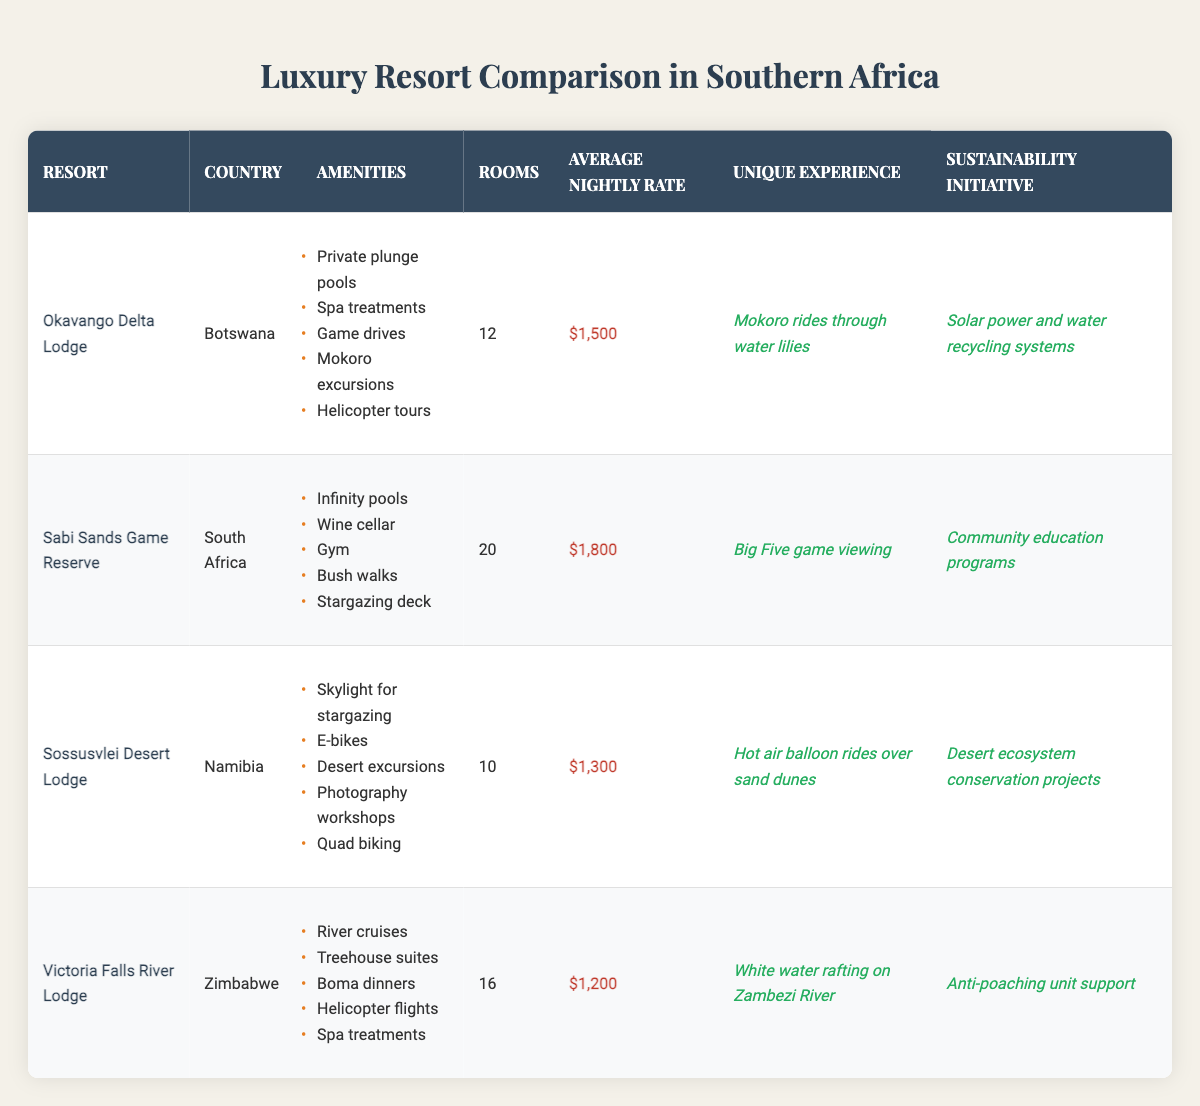What is the average nightly rate of the resorts in Botswana? The average nightly rate for the resorts in Botswana is based on the listing of one resort, Okavango Delta Lodge, which has an average nightly rate of $1,500. Since there is only one resort listed in Botswana, its rate serves as the average rate for that country.
Answer: 1500 How many total rooms are available across all the resorts listed? To find the total number of rooms, we need to sum the rooms available in each resort: 12 (Okavango Delta Lodge) + 20 (Sabi Sands Game Reserve) + 10 (Sossusvlei Desert Lodge) + 16 (Victoria Falls River Lodge) = 58 rooms total.
Answer: 58 Which resort has the highest average nightly rate? From examining the average nightly rates, Sabi Sands Game Reserve has the highest rate at $1,800, while the others are lower. This can be confirmed by comparing each rate listed: $1,500, $1,800, $1,300, and $1,200.
Answer: Sabi Sands Game Reserve Does the Victoria Falls River Lodge offer a spa treatment? No, the amenities listed for Victoria Falls River Lodge do not include spa treatments. Instead, its listed amenities are river cruises, treehouse suites, boma dinners, helicopter flights, and spa treatments. Since spa treatments are not specifically mentioned, the answer is negative.
Answer: No Which country has a resort that features unique experiences such as hot air balloon rides? The resort Sossusvlei Desert Lodge located in Namibia offers the unique experience of hot air balloon rides over sand dunes. This information is directly listed under the unique experience column for that specific resort.
Answer: Namibia Are all resorts located in Botswana primarily focused on eco-friendly sustainability initiatives? Yes, the Okavango Delta Lodge is noted for its sustainability initiative of solar power and water recycling systems, emphasizing its eco-friendly approach. Given that this is the only resort in Botswana listed, the focus remains on its commitment to sustainability.
Answer: Yes How does the number of rooms at Sossusvlei Desert Lodge compare to that of Okavango Delta Lodge? Sossusvlei Desert Lodge has 10 rooms, while Okavango Delta Lodge has 12 rooms. Thus, Sossusvlei Desert Lodge has 2 fewer rooms than Okavango Delta Lodge, indicating a lesser accommodation capacity.
Answer: 2 rooms fewer What is the total average nightly rate of resorts in South Africa compared to those in neighboring countries? The average nightly rate for South Africa, represented by Sabi Sands Game Reserve, is $1,800. The average rates for the neighboring countries are $1,500 (Botswana), $1,300 (Namibia), and $1,200 (Zimbabwe). Summing these gives (1500 + 1300 + 1200) = 4000 divided by three resorts gives an average of about $1,333. South Africa's rate is higher than the average rate of neighboring countries.
Answer: South Africa is higher 